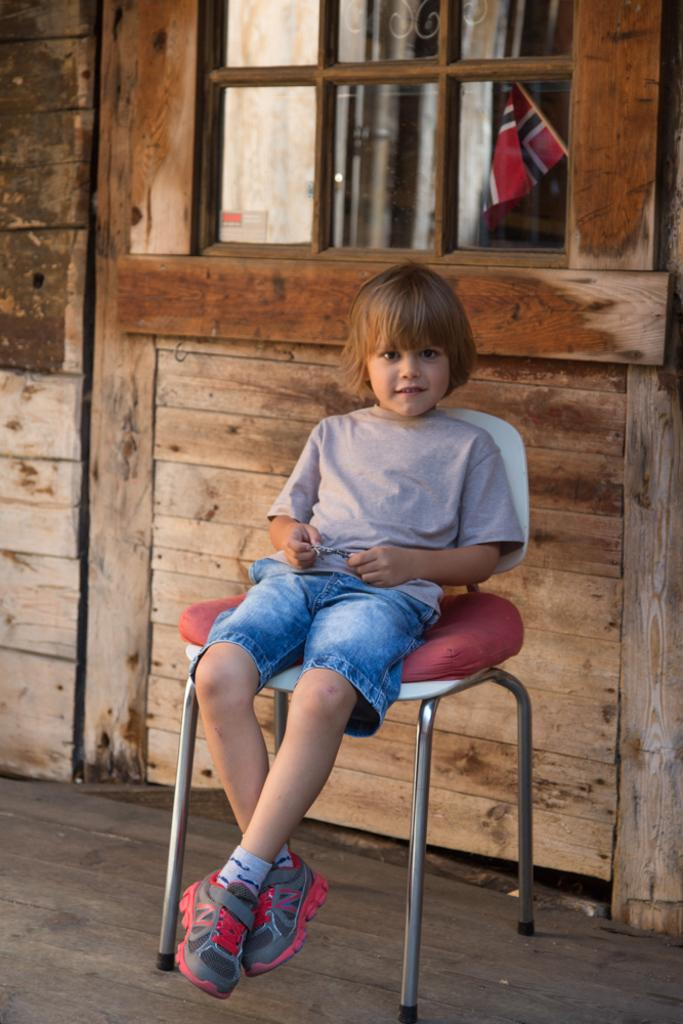What is the person in the image doing? The person is sitting on a chair in the image. What is the person's facial expression? The person is smiling. What can be seen behind the person? There is a window behind the person. What is visible through the window? A flag is visible through the window. What fact about the person's mind can be determined from the image? There is no information about the person's mind in the image, so it cannot be determined. 